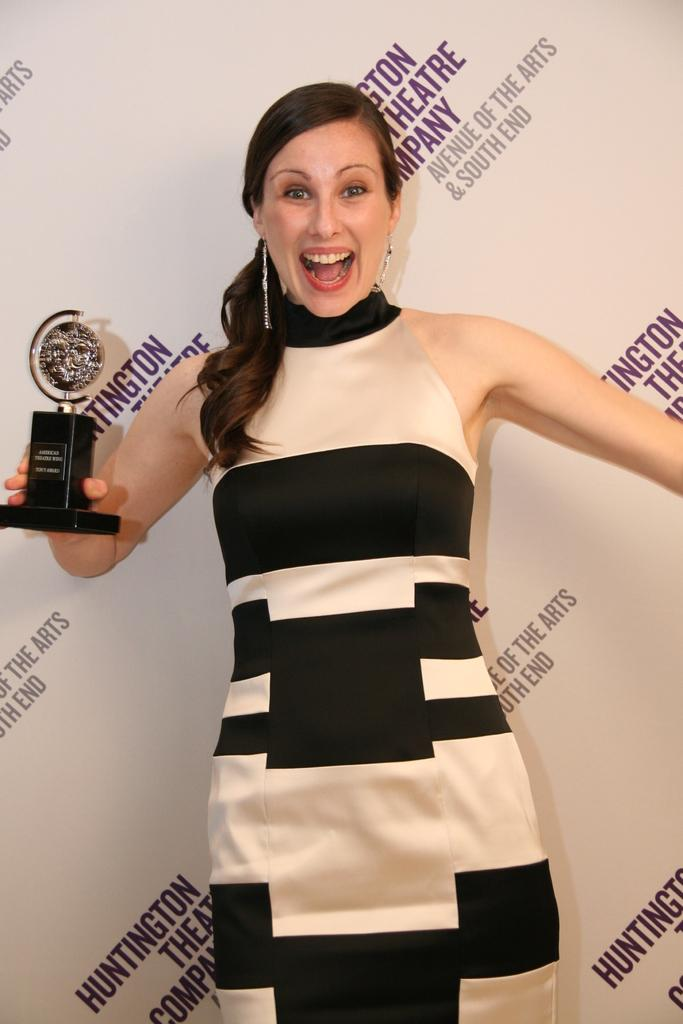<image>
Present a compact description of the photo's key features. A woman in a dress holds an award in front of a banner reading Huntington Theatre Company 